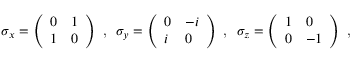<formula> <loc_0><loc_0><loc_500><loc_500>\begin{array} { r } { \sigma _ { x } = \left ( \begin{array} { l l } { 0 } & { 1 } \\ { 1 } & { 0 } \end{array} \right ) , \ \sigma _ { y } = \left ( \begin{array} { l l } { 0 } & { - i } \\ { i } & { 0 } \end{array} \right ) , \ \sigma _ { z } = \left ( \begin{array} { l l } { 1 } & { 0 } \\ { 0 } & { - 1 } \end{array} \right ) , \ } \end{array}</formula> 